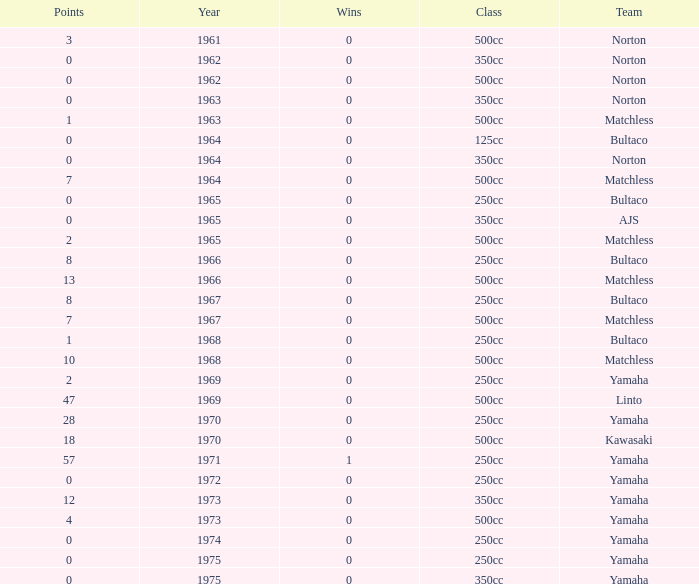What is the sum of all points in 1975 with 0 wins? None. 